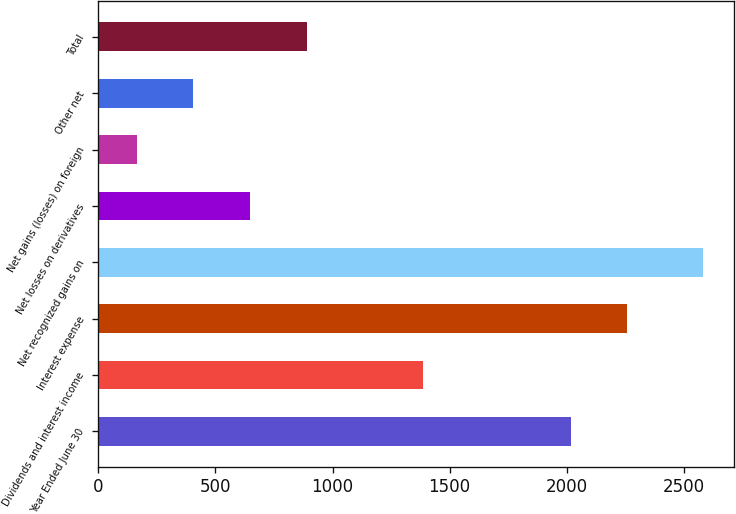Convert chart to OTSL. <chart><loc_0><loc_0><loc_500><loc_500><bar_chart><fcel>Year Ended June 30<fcel>Dividends and interest income<fcel>Interest expense<fcel>Net recognized gains on<fcel>Net losses on derivatives<fcel>Net gains (losses) on foreign<fcel>Other net<fcel>Total<nl><fcel>2017<fcel>1387<fcel>2258.9<fcel>2583<fcel>647.8<fcel>164<fcel>405.9<fcel>889.7<nl></chart> 